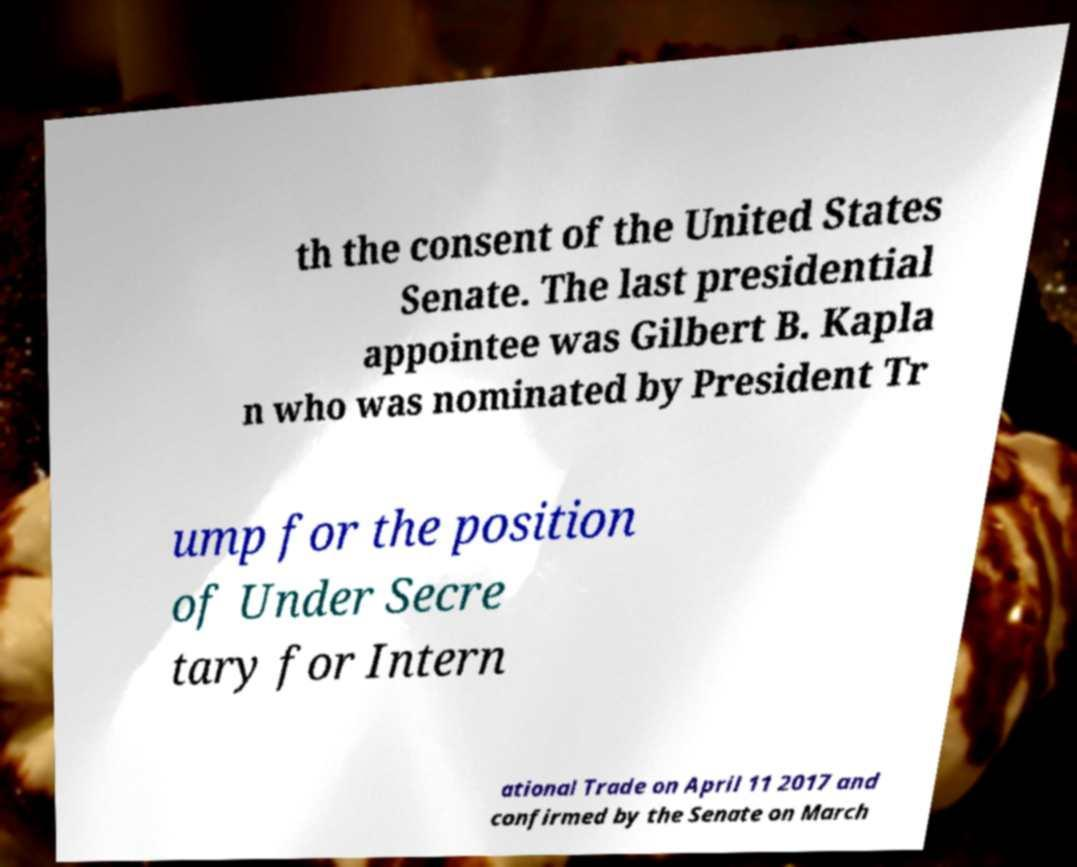Can you accurately transcribe the text from the provided image for me? th the consent of the United States Senate. The last presidential appointee was Gilbert B. Kapla n who was nominated by President Tr ump for the position of Under Secre tary for Intern ational Trade on April 11 2017 and confirmed by the Senate on March 